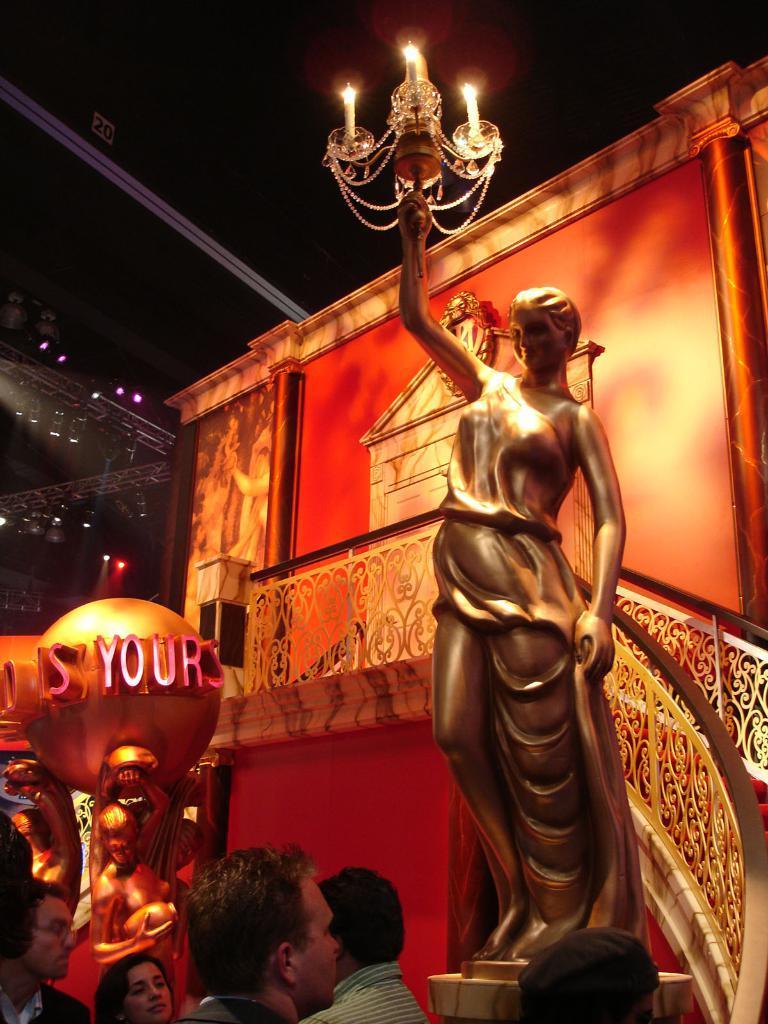In one or two sentences, can you explain what this image depicts? In this image we can see a statue in golden color, it is holding the candles in the hand, here is the staircase, here are the group of people standing, here is the wall, here are the lights. 